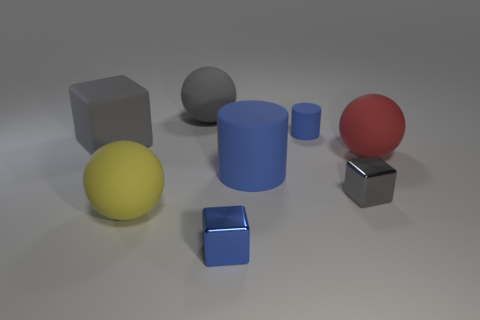How many objects are in the image, and can you classify them by material? There are six objects in the image. They can be classified by material into two categories: there appear to be three rubber objects, which are the large blue cylinder, the small blue cylinder, and the red sphere; and three metallic objects, which are the two cubes and the gray sphere. 